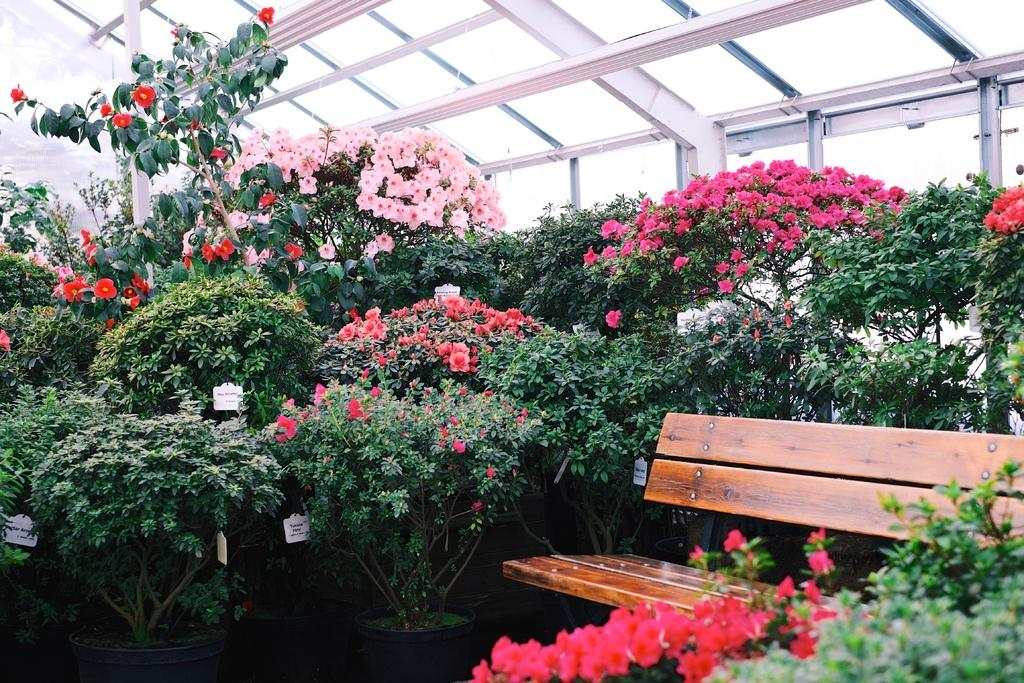Where was the image taken? The image was taken outside of a house. What can be seen in the background of the image? There are trees and beautiful flowers in the background of the image. What is the shortest route to the operation room from the point where the image was taken? There is no operation room or point mentioned in the image, so it is not possible to determine the shortest route. 